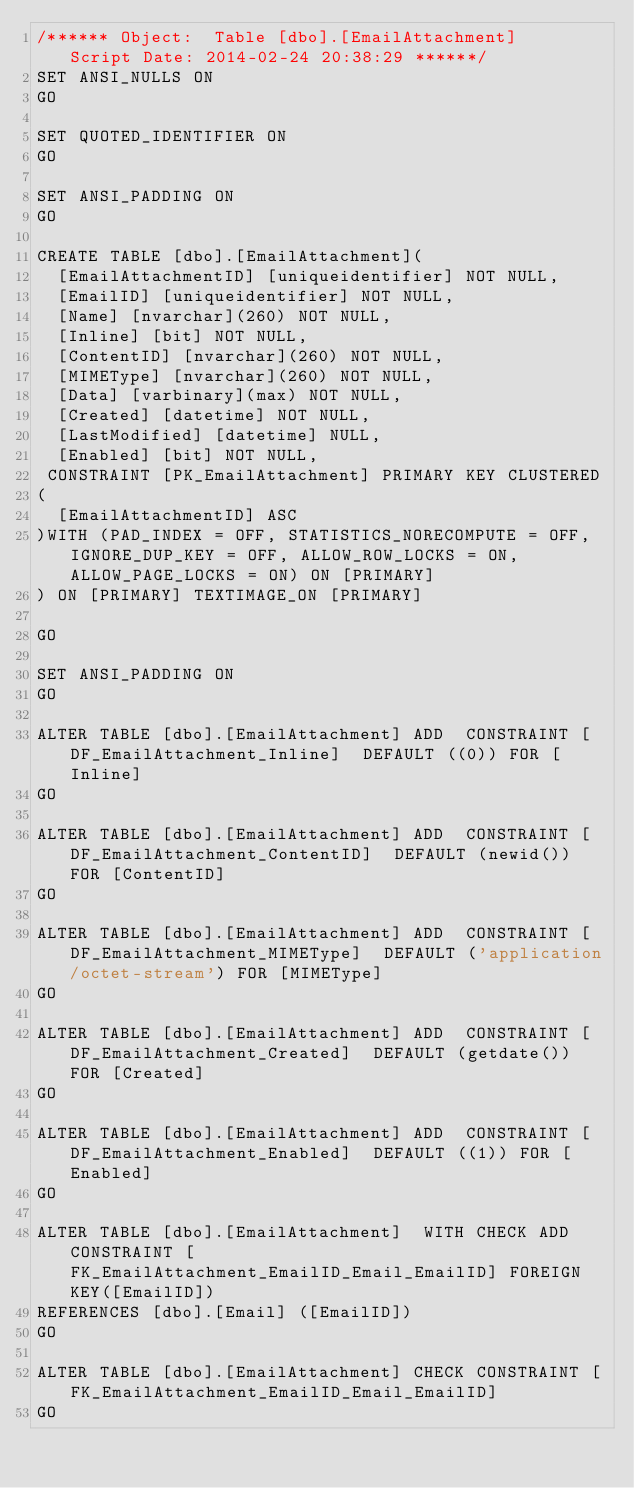Convert code to text. <code><loc_0><loc_0><loc_500><loc_500><_SQL_>/****** Object:  Table [dbo].[EmailAttachment]    Script Date: 2014-02-24 20:38:29 ******/
SET ANSI_NULLS ON
GO

SET QUOTED_IDENTIFIER ON
GO

SET ANSI_PADDING ON
GO

CREATE TABLE [dbo].[EmailAttachment](
	[EmailAttachmentID] [uniqueidentifier] NOT NULL,
	[EmailID] [uniqueidentifier] NOT NULL,
	[Name] [nvarchar](260) NOT NULL,
	[Inline] [bit] NOT NULL,
	[ContentID] [nvarchar](260) NOT NULL,
	[MIMEType] [nvarchar](260) NOT NULL,
	[Data] [varbinary](max) NOT NULL,
	[Created] [datetime] NOT NULL,
	[LastModified] [datetime] NULL,
	[Enabled] [bit] NOT NULL,
 CONSTRAINT [PK_EmailAttachment] PRIMARY KEY CLUSTERED 
(
	[EmailAttachmentID] ASC
)WITH (PAD_INDEX = OFF, STATISTICS_NORECOMPUTE = OFF, IGNORE_DUP_KEY = OFF, ALLOW_ROW_LOCKS = ON, ALLOW_PAGE_LOCKS = ON) ON [PRIMARY]
) ON [PRIMARY] TEXTIMAGE_ON [PRIMARY]

GO

SET ANSI_PADDING ON
GO

ALTER TABLE [dbo].[EmailAttachment] ADD  CONSTRAINT [DF_EmailAttachment_Inline]  DEFAULT ((0)) FOR [Inline]
GO

ALTER TABLE [dbo].[EmailAttachment] ADD  CONSTRAINT [DF_EmailAttachment_ContentID]  DEFAULT (newid()) FOR [ContentID]
GO

ALTER TABLE [dbo].[EmailAttachment] ADD  CONSTRAINT [DF_EmailAttachment_MIMEType]  DEFAULT ('application/octet-stream') FOR [MIMEType]
GO

ALTER TABLE [dbo].[EmailAttachment] ADD  CONSTRAINT [DF_EmailAttachment_Created]  DEFAULT (getdate()) FOR [Created]
GO

ALTER TABLE [dbo].[EmailAttachment] ADD  CONSTRAINT [DF_EmailAttachment_Enabled]  DEFAULT ((1)) FOR [Enabled]
GO

ALTER TABLE [dbo].[EmailAttachment]  WITH CHECK ADD  CONSTRAINT [FK_EmailAttachment_EmailID_Email_EmailID] FOREIGN KEY([EmailID])
REFERENCES [dbo].[Email] ([EmailID])
GO

ALTER TABLE [dbo].[EmailAttachment] CHECK CONSTRAINT [FK_EmailAttachment_EmailID_Email_EmailID]
GO


</code> 